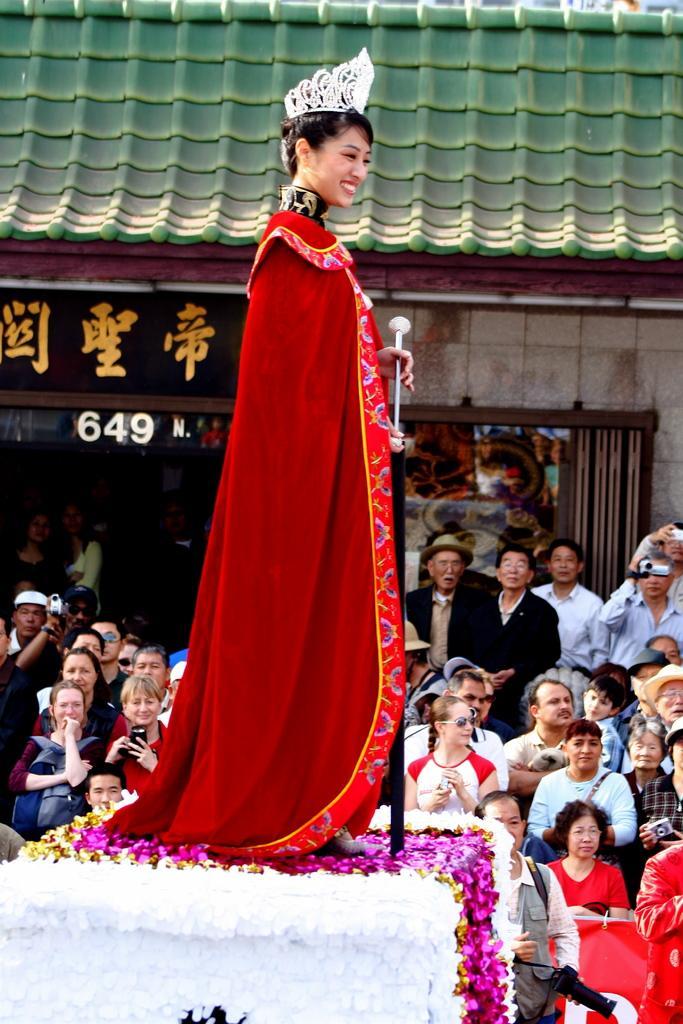Can you describe this image briefly? In the center of the image we can see a lady standing and smiling. She is wearing a crown. At the bottom there is crowd sitting and some of them are holding cameras. In the background there is a shed and we can see a board. At the bottom we can see decors. 